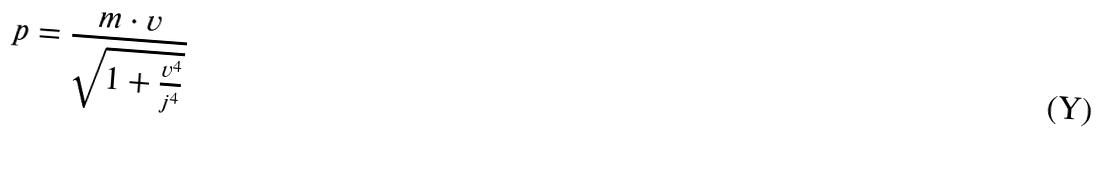Convert formula to latex. <formula><loc_0><loc_0><loc_500><loc_500>p = \frac { m \cdot v } { \sqrt { 1 + \frac { v ^ { 4 } } { j ^ { 4 } } } }</formula> 